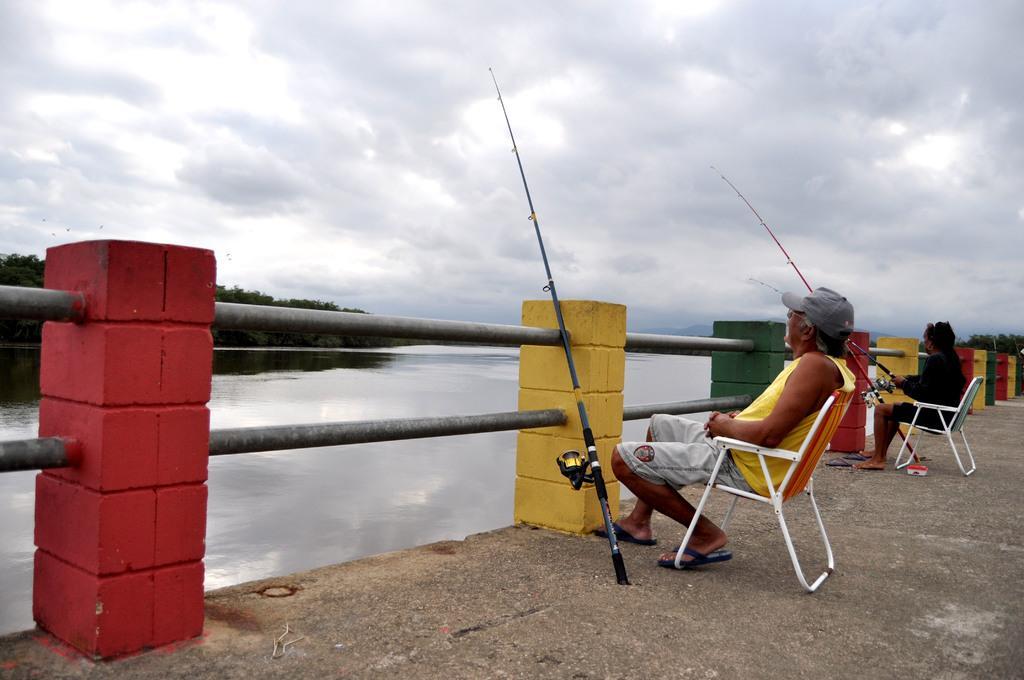Could you give a brief overview of what you see in this image? In the foreground of the image, there are two men sitting on the chairs and fishing. As we can see fishing rods near railing. In the background, there is water, trees and the sky. 